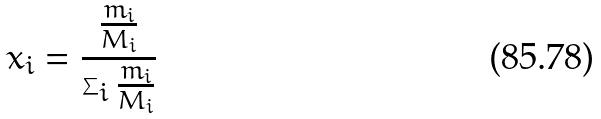<formula> <loc_0><loc_0><loc_500><loc_500>x _ { i } = \frac { \frac { m _ { i } } { M _ { i } } } { \sum _ { i } \frac { m _ { i } } { M _ { i } } }</formula> 